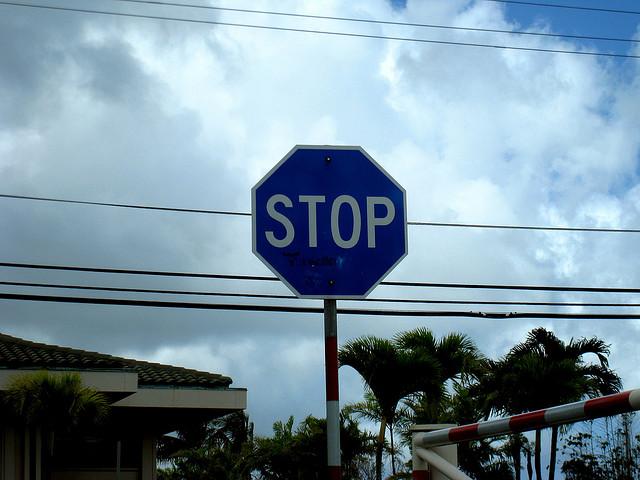What shape is the stop sign?
Quick response, please. Octagon. In what way does this sign appear unusual?
Give a very brief answer. It's blue. What color should this sign be?
Quick response, please. Red. 